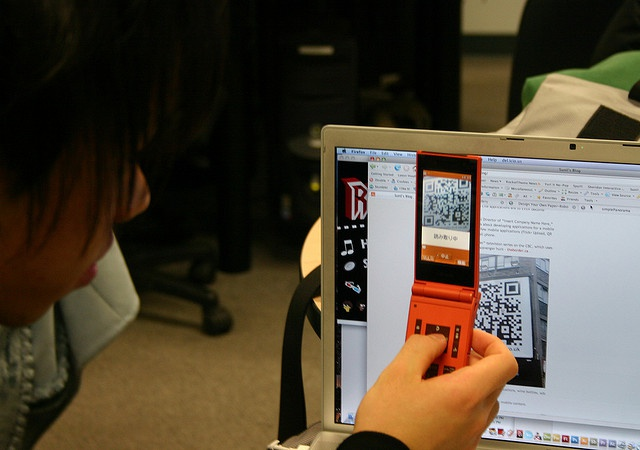Describe the objects in this image and their specific colors. I can see laptop in black, lightgray, and darkgray tones, people in black, darkgreen, maroon, and olive tones, people in black, orange, brown, and red tones, cell phone in black, red, brown, and darkgray tones, and chair in black tones in this image. 